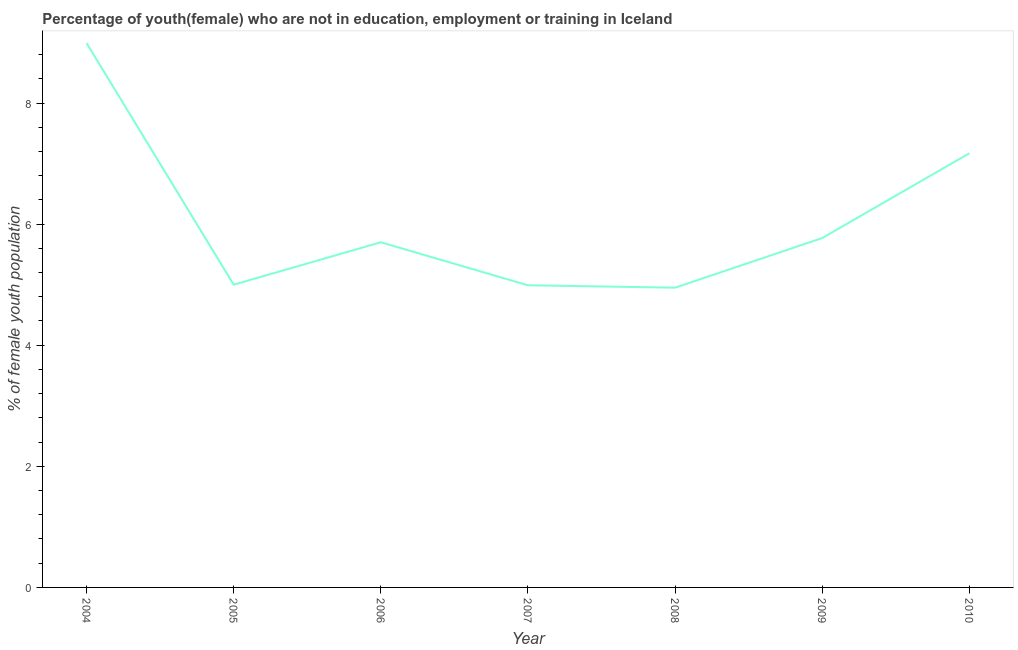What is the unemployed female youth population in 2006?
Provide a short and direct response. 5.7. Across all years, what is the maximum unemployed female youth population?
Ensure brevity in your answer.  8.99. Across all years, what is the minimum unemployed female youth population?
Your response must be concise. 4.95. In which year was the unemployed female youth population maximum?
Make the answer very short. 2004. What is the sum of the unemployed female youth population?
Give a very brief answer. 42.57. What is the difference between the unemployed female youth population in 2004 and 2006?
Provide a succinct answer. 3.29. What is the average unemployed female youth population per year?
Your answer should be compact. 6.08. What is the median unemployed female youth population?
Ensure brevity in your answer.  5.7. Do a majority of the years between 2004 and 2008 (inclusive) have unemployed female youth population greater than 1.6 %?
Your answer should be compact. Yes. What is the ratio of the unemployed female youth population in 2007 to that in 2008?
Your answer should be very brief. 1.01. Is the unemployed female youth population in 2005 less than that in 2009?
Offer a terse response. Yes. Is the difference between the unemployed female youth population in 2006 and 2010 greater than the difference between any two years?
Provide a short and direct response. No. What is the difference between the highest and the second highest unemployed female youth population?
Offer a very short reply. 1.82. What is the difference between the highest and the lowest unemployed female youth population?
Provide a succinct answer. 4.04. What is the difference between two consecutive major ticks on the Y-axis?
Ensure brevity in your answer.  2. Are the values on the major ticks of Y-axis written in scientific E-notation?
Ensure brevity in your answer.  No. Does the graph contain any zero values?
Provide a short and direct response. No. What is the title of the graph?
Your response must be concise. Percentage of youth(female) who are not in education, employment or training in Iceland. What is the label or title of the X-axis?
Your answer should be very brief. Year. What is the label or title of the Y-axis?
Provide a succinct answer. % of female youth population. What is the % of female youth population in 2004?
Keep it short and to the point. 8.99. What is the % of female youth population in 2006?
Your answer should be very brief. 5.7. What is the % of female youth population of 2007?
Make the answer very short. 4.99. What is the % of female youth population in 2008?
Provide a succinct answer. 4.95. What is the % of female youth population of 2009?
Ensure brevity in your answer.  5.77. What is the % of female youth population in 2010?
Make the answer very short. 7.17. What is the difference between the % of female youth population in 2004 and 2005?
Offer a very short reply. 3.99. What is the difference between the % of female youth population in 2004 and 2006?
Give a very brief answer. 3.29. What is the difference between the % of female youth population in 2004 and 2007?
Ensure brevity in your answer.  4. What is the difference between the % of female youth population in 2004 and 2008?
Ensure brevity in your answer.  4.04. What is the difference between the % of female youth population in 2004 and 2009?
Offer a very short reply. 3.22. What is the difference between the % of female youth population in 2004 and 2010?
Your response must be concise. 1.82. What is the difference between the % of female youth population in 2005 and 2009?
Give a very brief answer. -0.77. What is the difference between the % of female youth population in 2005 and 2010?
Give a very brief answer. -2.17. What is the difference between the % of female youth population in 2006 and 2007?
Your answer should be very brief. 0.71. What is the difference between the % of female youth population in 2006 and 2008?
Keep it short and to the point. 0.75. What is the difference between the % of female youth population in 2006 and 2009?
Provide a succinct answer. -0.07. What is the difference between the % of female youth population in 2006 and 2010?
Your answer should be compact. -1.47. What is the difference between the % of female youth population in 2007 and 2009?
Provide a succinct answer. -0.78. What is the difference between the % of female youth population in 2007 and 2010?
Give a very brief answer. -2.18. What is the difference between the % of female youth population in 2008 and 2009?
Give a very brief answer. -0.82. What is the difference between the % of female youth population in 2008 and 2010?
Give a very brief answer. -2.22. What is the difference between the % of female youth population in 2009 and 2010?
Provide a succinct answer. -1.4. What is the ratio of the % of female youth population in 2004 to that in 2005?
Your response must be concise. 1.8. What is the ratio of the % of female youth population in 2004 to that in 2006?
Your response must be concise. 1.58. What is the ratio of the % of female youth population in 2004 to that in 2007?
Your answer should be very brief. 1.8. What is the ratio of the % of female youth population in 2004 to that in 2008?
Your answer should be compact. 1.82. What is the ratio of the % of female youth population in 2004 to that in 2009?
Give a very brief answer. 1.56. What is the ratio of the % of female youth population in 2004 to that in 2010?
Offer a very short reply. 1.25. What is the ratio of the % of female youth population in 2005 to that in 2006?
Ensure brevity in your answer.  0.88. What is the ratio of the % of female youth population in 2005 to that in 2007?
Offer a very short reply. 1. What is the ratio of the % of female youth population in 2005 to that in 2009?
Offer a terse response. 0.87. What is the ratio of the % of female youth population in 2005 to that in 2010?
Give a very brief answer. 0.7. What is the ratio of the % of female youth population in 2006 to that in 2007?
Your response must be concise. 1.14. What is the ratio of the % of female youth population in 2006 to that in 2008?
Your answer should be compact. 1.15. What is the ratio of the % of female youth population in 2006 to that in 2009?
Your answer should be compact. 0.99. What is the ratio of the % of female youth population in 2006 to that in 2010?
Offer a very short reply. 0.8. What is the ratio of the % of female youth population in 2007 to that in 2009?
Provide a short and direct response. 0.86. What is the ratio of the % of female youth population in 2007 to that in 2010?
Provide a short and direct response. 0.7. What is the ratio of the % of female youth population in 2008 to that in 2009?
Give a very brief answer. 0.86. What is the ratio of the % of female youth population in 2008 to that in 2010?
Your answer should be compact. 0.69. What is the ratio of the % of female youth population in 2009 to that in 2010?
Your answer should be compact. 0.81. 